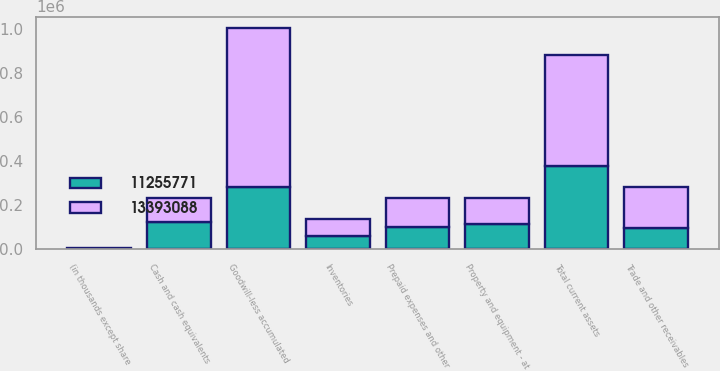Convert chart to OTSL. <chart><loc_0><loc_0><loc_500><loc_500><stacked_bar_chart><ecel><fcel>(in thousands except share<fcel>Cash and cash equivalents<fcel>Trade and other receivables<fcel>Inventories<fcel>Prepaid expenses and other<fcel>Total current assets<fcel>Property and equipment - at<fcel>Goodwill-less accumulated<nl><fcel>1.33931e+07<fcel>2006<fcel>104520<fcel>185886<fcel>76969<fcel>134529<fcel>501904<fcel>114952<fcel>721514<nl><fcel>1.12558e+07<fcel>2005<fcel>125385<fcel>95254<fcel>57803<fcel>98568<fcel>377010<fcel>114952<fcel>283133<nl></chart> 